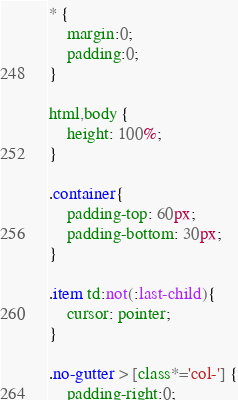Convert code to text. <code><loc_0><loc_0><loc_500><loc_500><_CSS_>* {
	margin:0;
	padding:0;
}

html,body {
	height: 100%;
}

.container{
	padding-top: 60px;
	padding-bottom: 30px;
}

.item td:not(:last-child){
	cursor: pointer;
}

.no-gutter > [class*='col-'] {
	padding-right:0;</code> 